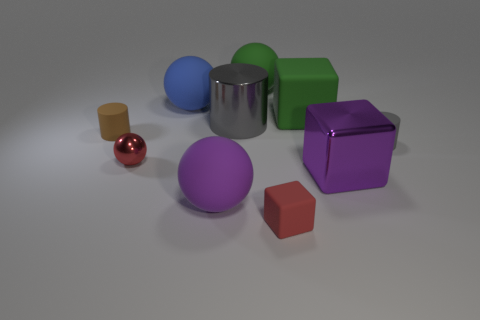Subtract all big blocks. How many blocks are left? 1 Subtract all gray cylinders. How many cylinders are left? 1 Subtract 3 spheres. How many spheres are left? 1 Subtract all blocks. How many objects are left? 7 Add 7 tiny gray spheres. How many tiny gray spheres exist? 7 Subtract 1 red balls. How many objects are left? 9 Subtract all cyan blocks. Subtract all red balls. How many blocks are left? 3 Subtract all blue balls. How many yellow cylinders are left? 0 Subtract all small things. Subtract all brown rubber cylinders. How many objects are left? 5 Add 9 red rubber blocks. How many red rubber blocks are left? 10 